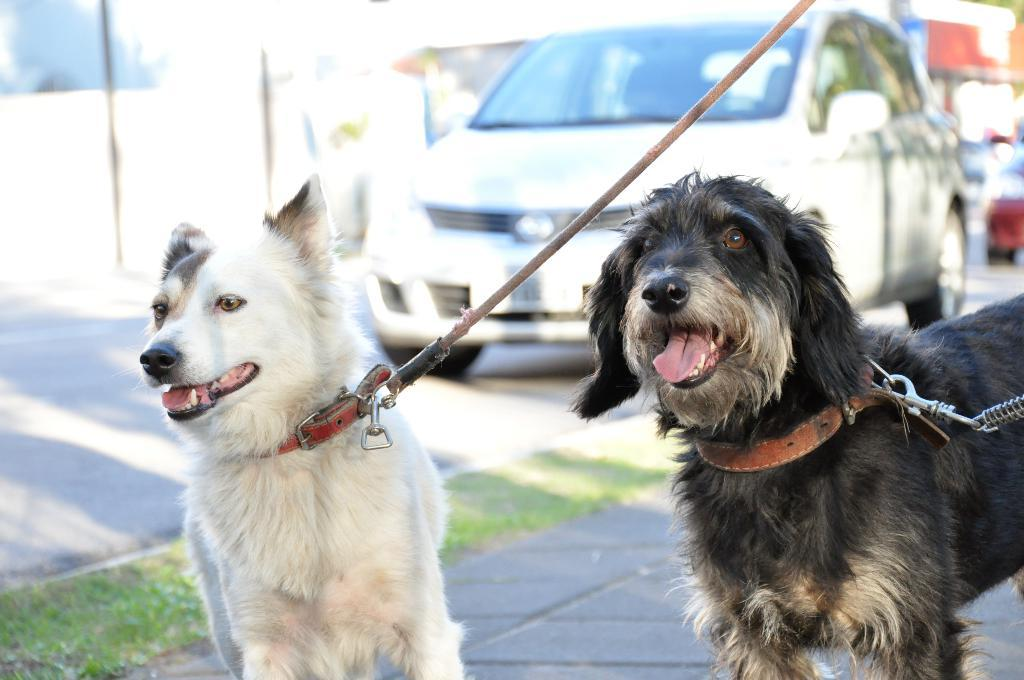What type of animals are in the image? There are dogs in the image. What are the dogs wearing? The dogs are wearing belts. Can you describe the background of the image? The background of the image is blurry. What type of vehicle is visible in the image? There is a car with wheels visible in the image. Where is the car located? The car is on the road. What page of the book does the crow appear on in the image? There is no book or crow present in the image. What is the dogs' afterthought while wearing the belts in the image? The provided facts do not give any information about the dogs' thoughts or feelings, so we cannot determine their afterthought. 